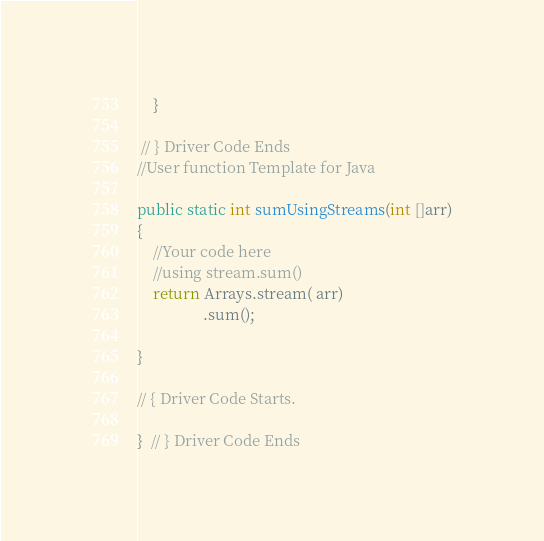Convert code to text. <code><loc_0><loc_0><loc_500><loc_500><_Java_>	}
	
 // } Driver Code Ends
//User function Template for Java

public static int sumUsingStreams(int []arr)
{
    //Your code here
    //using stream.sum()
    return Arrays.stream( arr)
                 .sum();  
    
}

// { Driver Code Starts.
	
}  // } Driver Code Ends</code> 